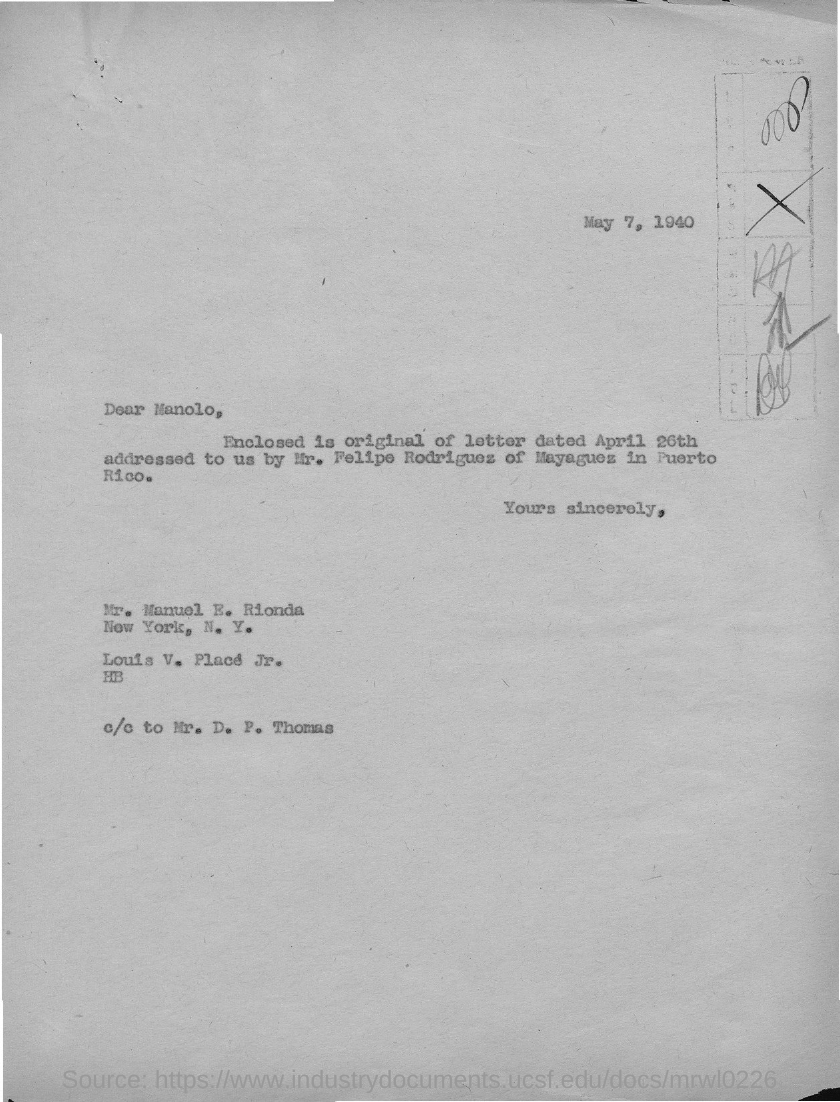Outline some significant characteristics in this image. The addressee of this letter is Manolo. The issued date of this letter is May 7, 1940. The sender of this letter is Louis V. Place Jr. 